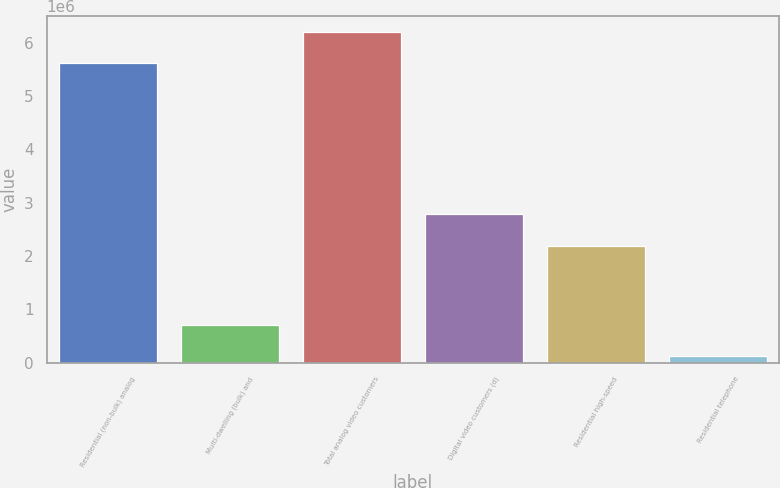<chart> <loc_0><loc_0><loc_500><loc_500><bar_chart><fcel>Residential (non-bulk) analog<fcel>Multi-dwelling (bulk) and<fcel>Total analog video customers<fcel>Digital video customers (d)<fcel>Residential high-speed<fcel>Residential telephone<nl><fcel>5.6163e+06<fcel>697800<fcel>6.1926e+06<fcel>2.7966e+06<fcel>2.1964e+06<fcel>121500<nl></chart> 